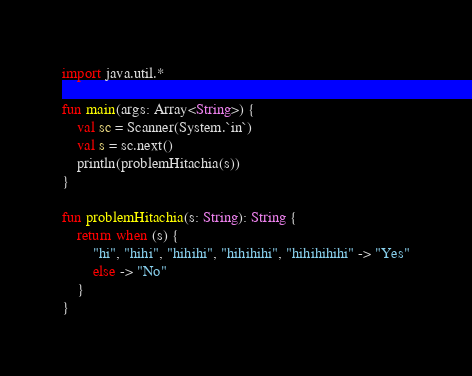<code> <loc_0><loc_0><loc_500><loc_500><_Kotlin_>import java.util.*

fun main(args: Array<String>) {
    val sc = Scanner(System.`in`)
    val s = sc.next()
    println(problemHitachia(s))
}

fun problemHitachia(s: String): String {
    return when (s) {
        "hi", "hihi", "hihihi", "hihihihi", "hihihihihi" -> "Yes"
        else -> "No"
    }
}</code> 